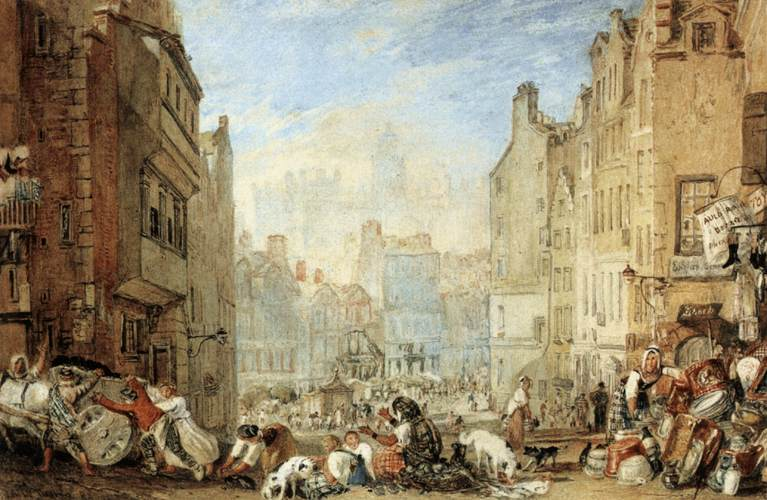If this scene were part of a story, what could be happening? Imagine a bustling market day in a European town. The protagonist, a young merchant, has just set up his stall. He is anxious because today he plans to propose to his beloved, who helps her family run a neighboring stall. As the day progresses and the market buzzes with activity, he finally gathers the courage. To the delight of onlookers, he kneels and offers a simple yet heartfelt proposal, symbolizing love amidst the daily grind of life. 